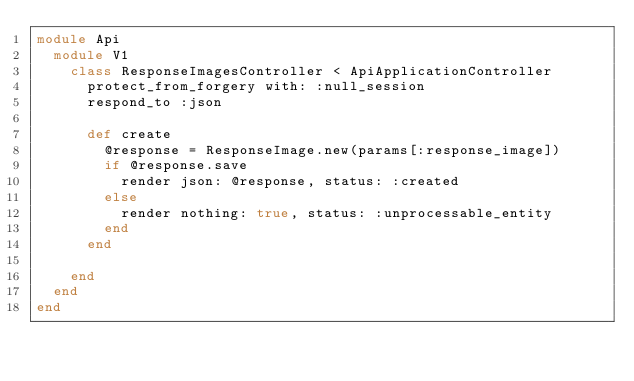Convert code to text. <code><loc_0><loc_0><loc_500><loc_500><_Ruby_>module Api
  module V1
    class ResponseImagesController < ApiApplicationController
      protect_from_forgery with: :null_session
      respond_to :json

      def create
        @response = ResponseImage.new(params[:response_image])
        if @response.save
          render json: @response, status: :created
        else
          render nothing: true, status: :unprocessable_entity
        end
      end
      
    end
  end
end
</code> 